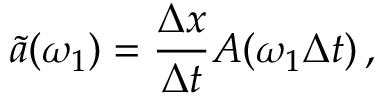Convert formula to latex. <formula><loc_0><loc_0><loc_500><loc_500>\tilde { a } ( \omega _ { 1 } ) = \frac { \Delta x } { \Delta t } A ( \omega _ { 1 } \Delta t ) \, ,</formula> 